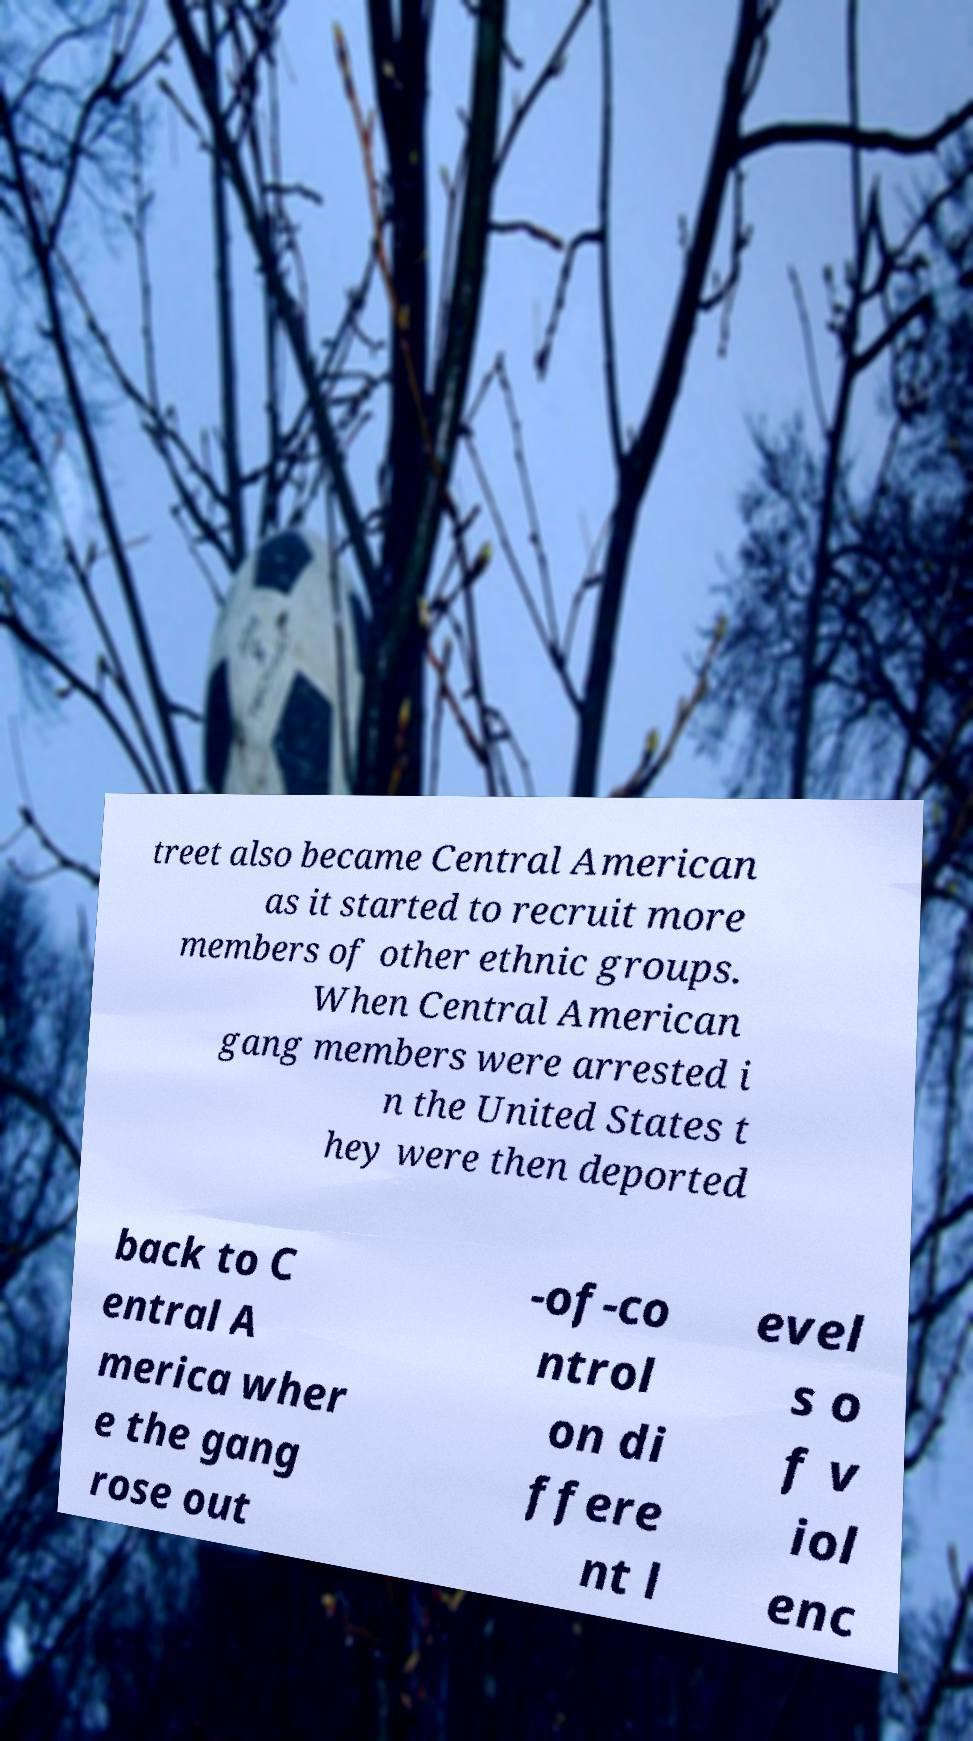Can you accurately transcribe the text from the provided image for me? treet also became Central American as it started to recruit more members of other ethnic groups. When Central American gang members were arrested i n the United States t hey were then deported back to C entral A merica wher e the gang rose out -of-co ntrol on di ffere nt l evel s o f v iol enc 